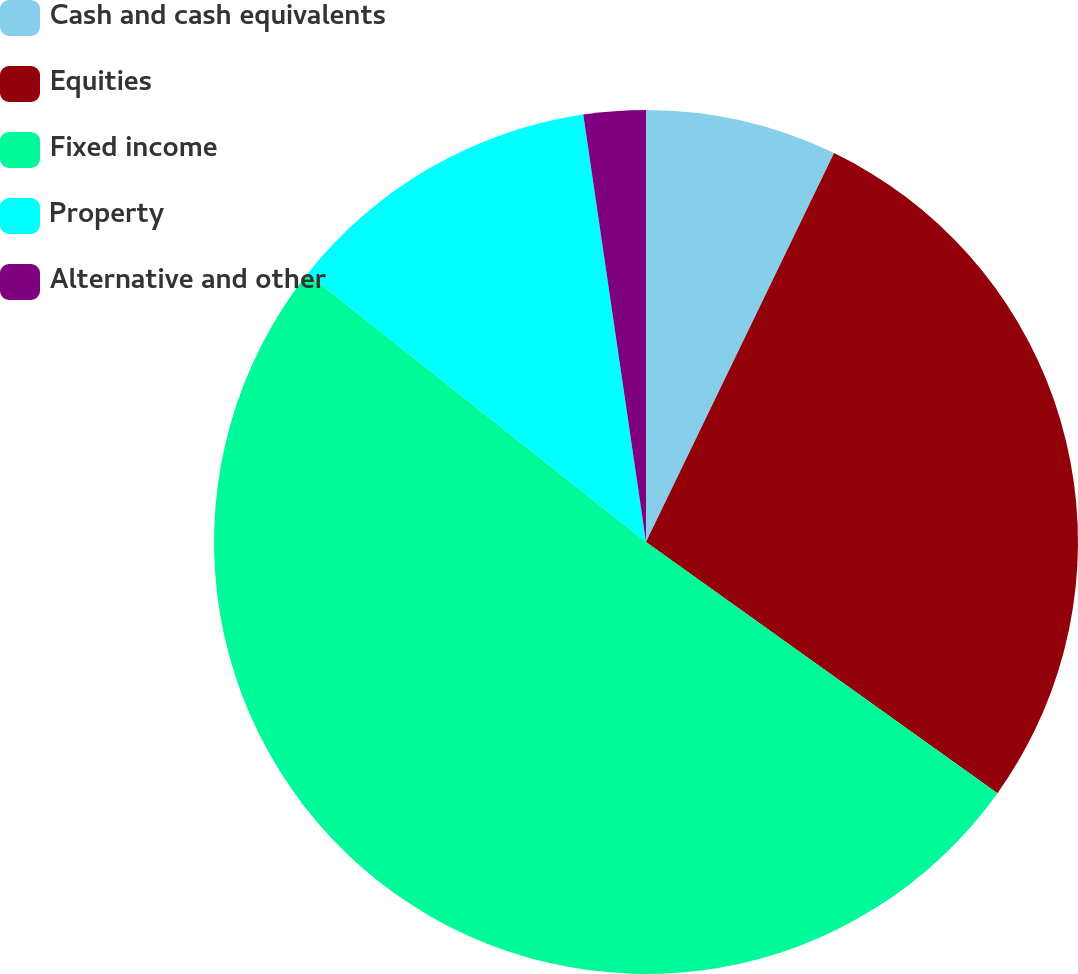Convert chart. <chart><loc_0><loc_0><loc_500><loc_500><pie_chart><fcel>Cash and cash equivalents<fcel>Equities<fcel>Fixed income<fcel>Property<fcel>Alternative and other<nl><fcel>7.17%<fcel>27.71%<fcel>50.79%<fcel>12.02%<fcel>2.32%<nl></chart> 